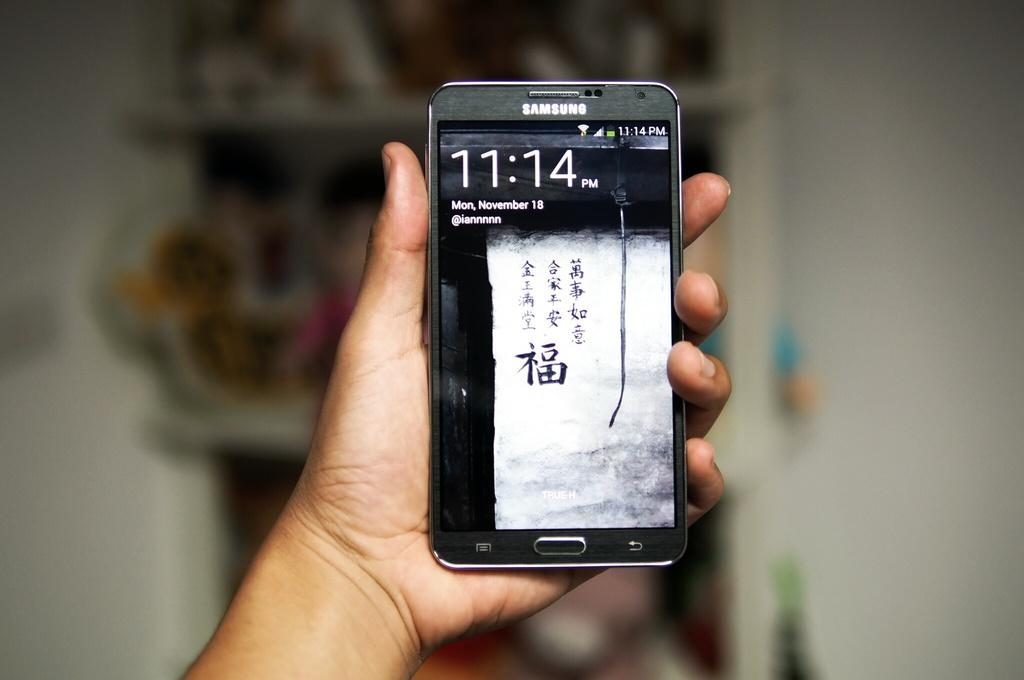Who or what is present in the image? There is a person in the image. What is the person holding in the image? The person is holding a mobile. What can be seen in the background of the image? There is a rack and a wall in the background of the image. What is on the rack in the image? There are objects visible on the rack. What type of nut is being used to secure the mobile to the wall in the image? There is no nut visible in the image, and the mobile is not being secured to the wall. 